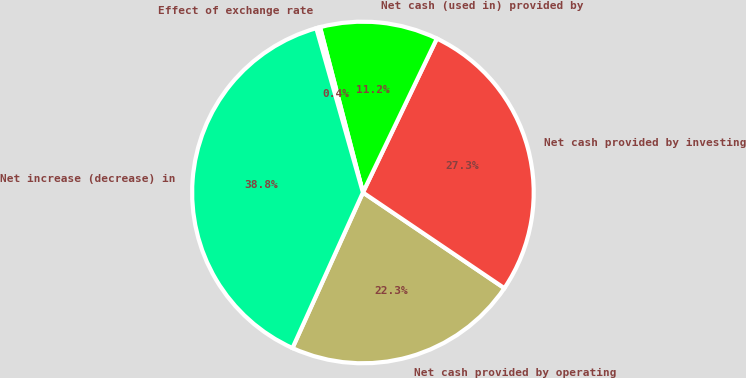<chart> <loc_0><loc_0><loc_500><loc_500><pie_chart><fcel>Net cash provided by operating<fcel>Net cash provided by investing<fcel>Net cash (used in) provided by<fcel>Effect of exchange rate<fcel>Net increase (decrease) in<nl><fcel>22.3%<fcel>27.34%<fcel>11.17%<fcel>0.36%<fcel>38.83%<nl></chart> 